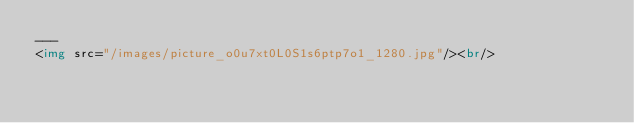<code> <loc_0><loc_0><loc_500><loc_500><_HTML_>---
<img src="/images/picture_o0u7xt0L0S1s6ptp7o1_1280.jpg"/><br/>
</code> 